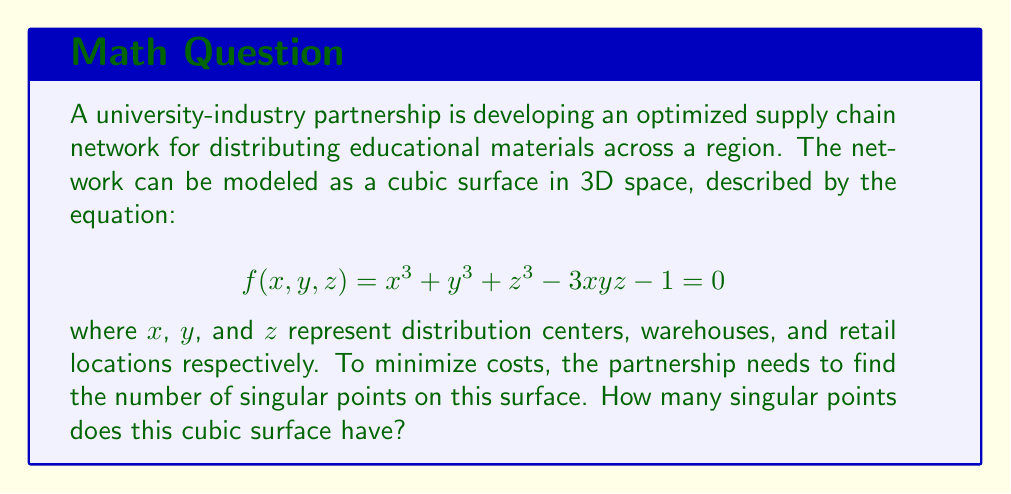What is the answer to this math problem? To find the singular points on the cubic surface, we need to follow these steps:

1) Singular points occur where all partial derivatives of $f(x,y,z)$ are simultaneously zero. Let's calculate these partial derivatives:

   $$\frac{\partial f}{\partial x} = 3x^2 - 3yz$$
   $$\frac{\partial f}{\partial y} = 3y^2 - 3xz$$
   $$\frac{\partial f}{\partial z} = 3z^2 - 3xy$$

2) Set each partial derivative to zero:

   $$3x^2 - 3yz = 0$$
   $$3y^2 - 3xz = 0$$
   $$3z^2 - 3xy = 0$$

3) From these equations, we can deduce:

   $$x^2 = yz$$
   $$y^2 = xz$$
   $$z^2 = xy$$

4) Multiplying these equations:

   $$x^2y^2z^2 = y^2z^2x^2$$

   This is always true, so it doesn't give us any new information.

5) Let's substitute $z^2 = xy$ into the original equation:

   $$x^3 + y^3 + (xy)^{3/2} - 3xy\sqrt{xy} - 1 = 0$$

6) For this to be true, we must have $x = y = z = 1$ or $x = y = z = \omega$ or $x = y = z = \omega^2$, where $\omega$ is a complex cube root of unity ($\omega^3 = 1$, $\omega \neq 1$).

7) Checking these points in the original equation:

   For $(1,1,1)$: $1 + 1 + 1 - 3(1)(1)(1) - 1 = 0$
   For $(\omega,\omega,\omega)$: $\omega^3 + \omega^3 + \omega^3 - 3\omega^3 - 1 = 0$
   For $(\omega^2,\omega^2,\omega^2)$: $(\omega^2)^3 + (\omega^2)^3 + (\omega^2)^3 - 3(\omega^2)^3 - 1 = 0$

8) Therefore, there are exactly 3 singular points on this cubic surface.
Answer: 3 singular points 